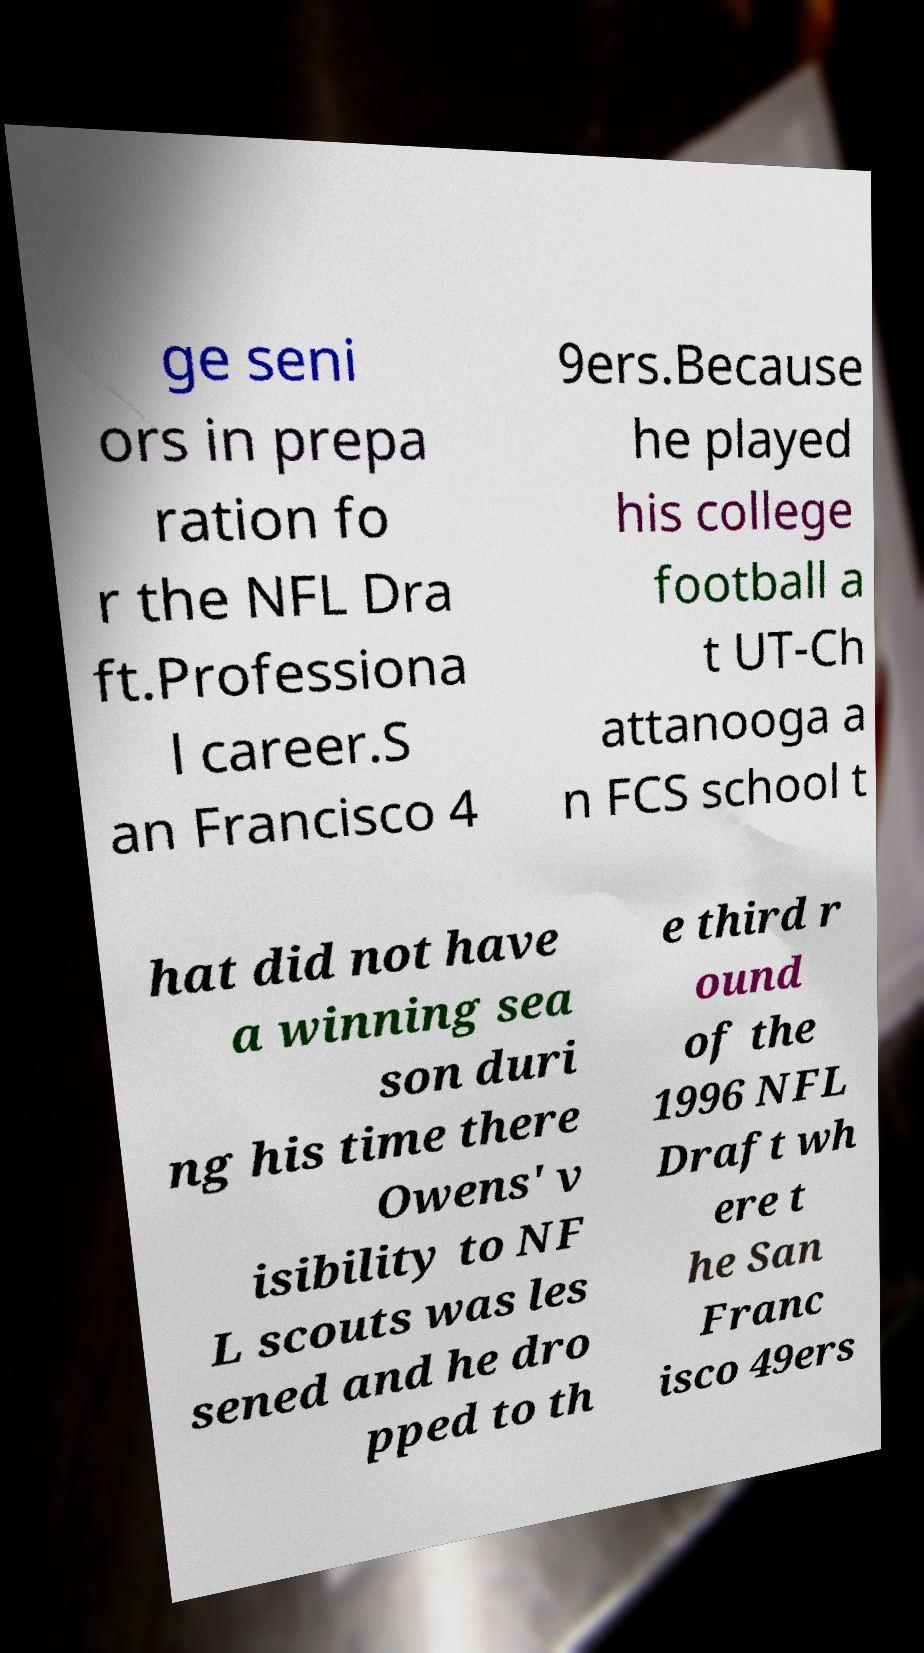I need the written content from this picture converted into text. Can you do that? ge seni ors in prepa ration fo r the NFL Dra ft.Professiona l career.S an Francisco 4 9ers.Because he played his college football a t UT-Ch attanooga a n FCS school t hat did not have a winning sea son duri ng his time there Owens' v isibility to NF L scouts was les sened and he dro pped to th e third r ound of the 1996 NFL Draft wh ere t he San Franc isco 49ers 